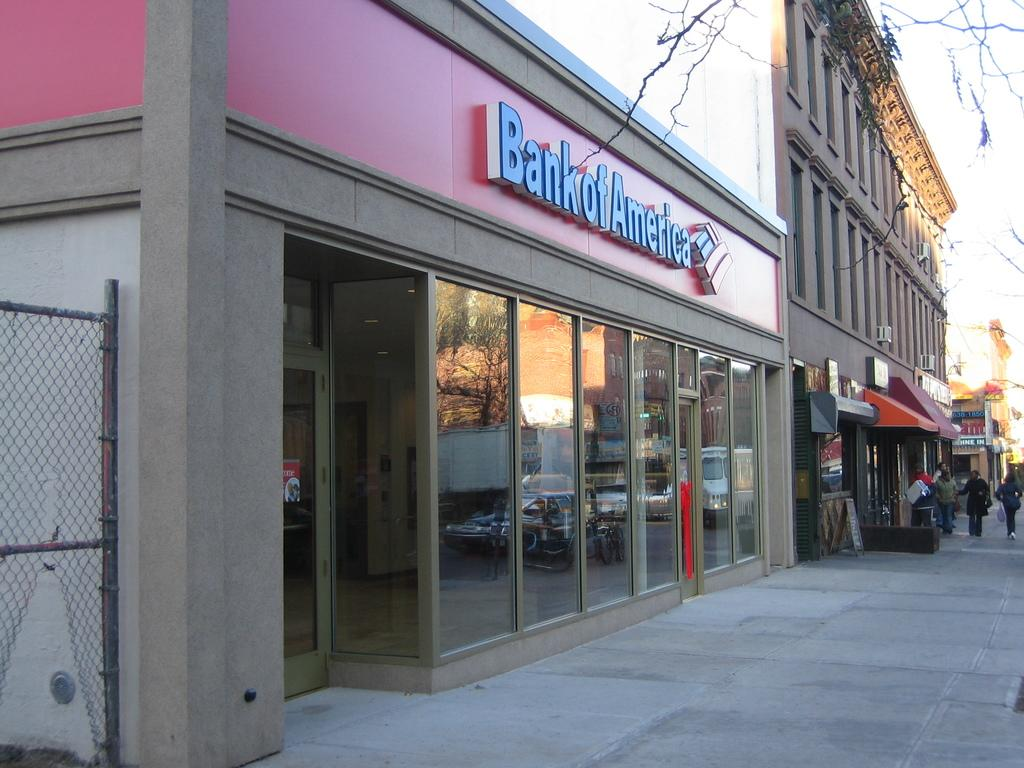<image>
Summarize the visual content of the image. A store front with the words Bank Of America above it 